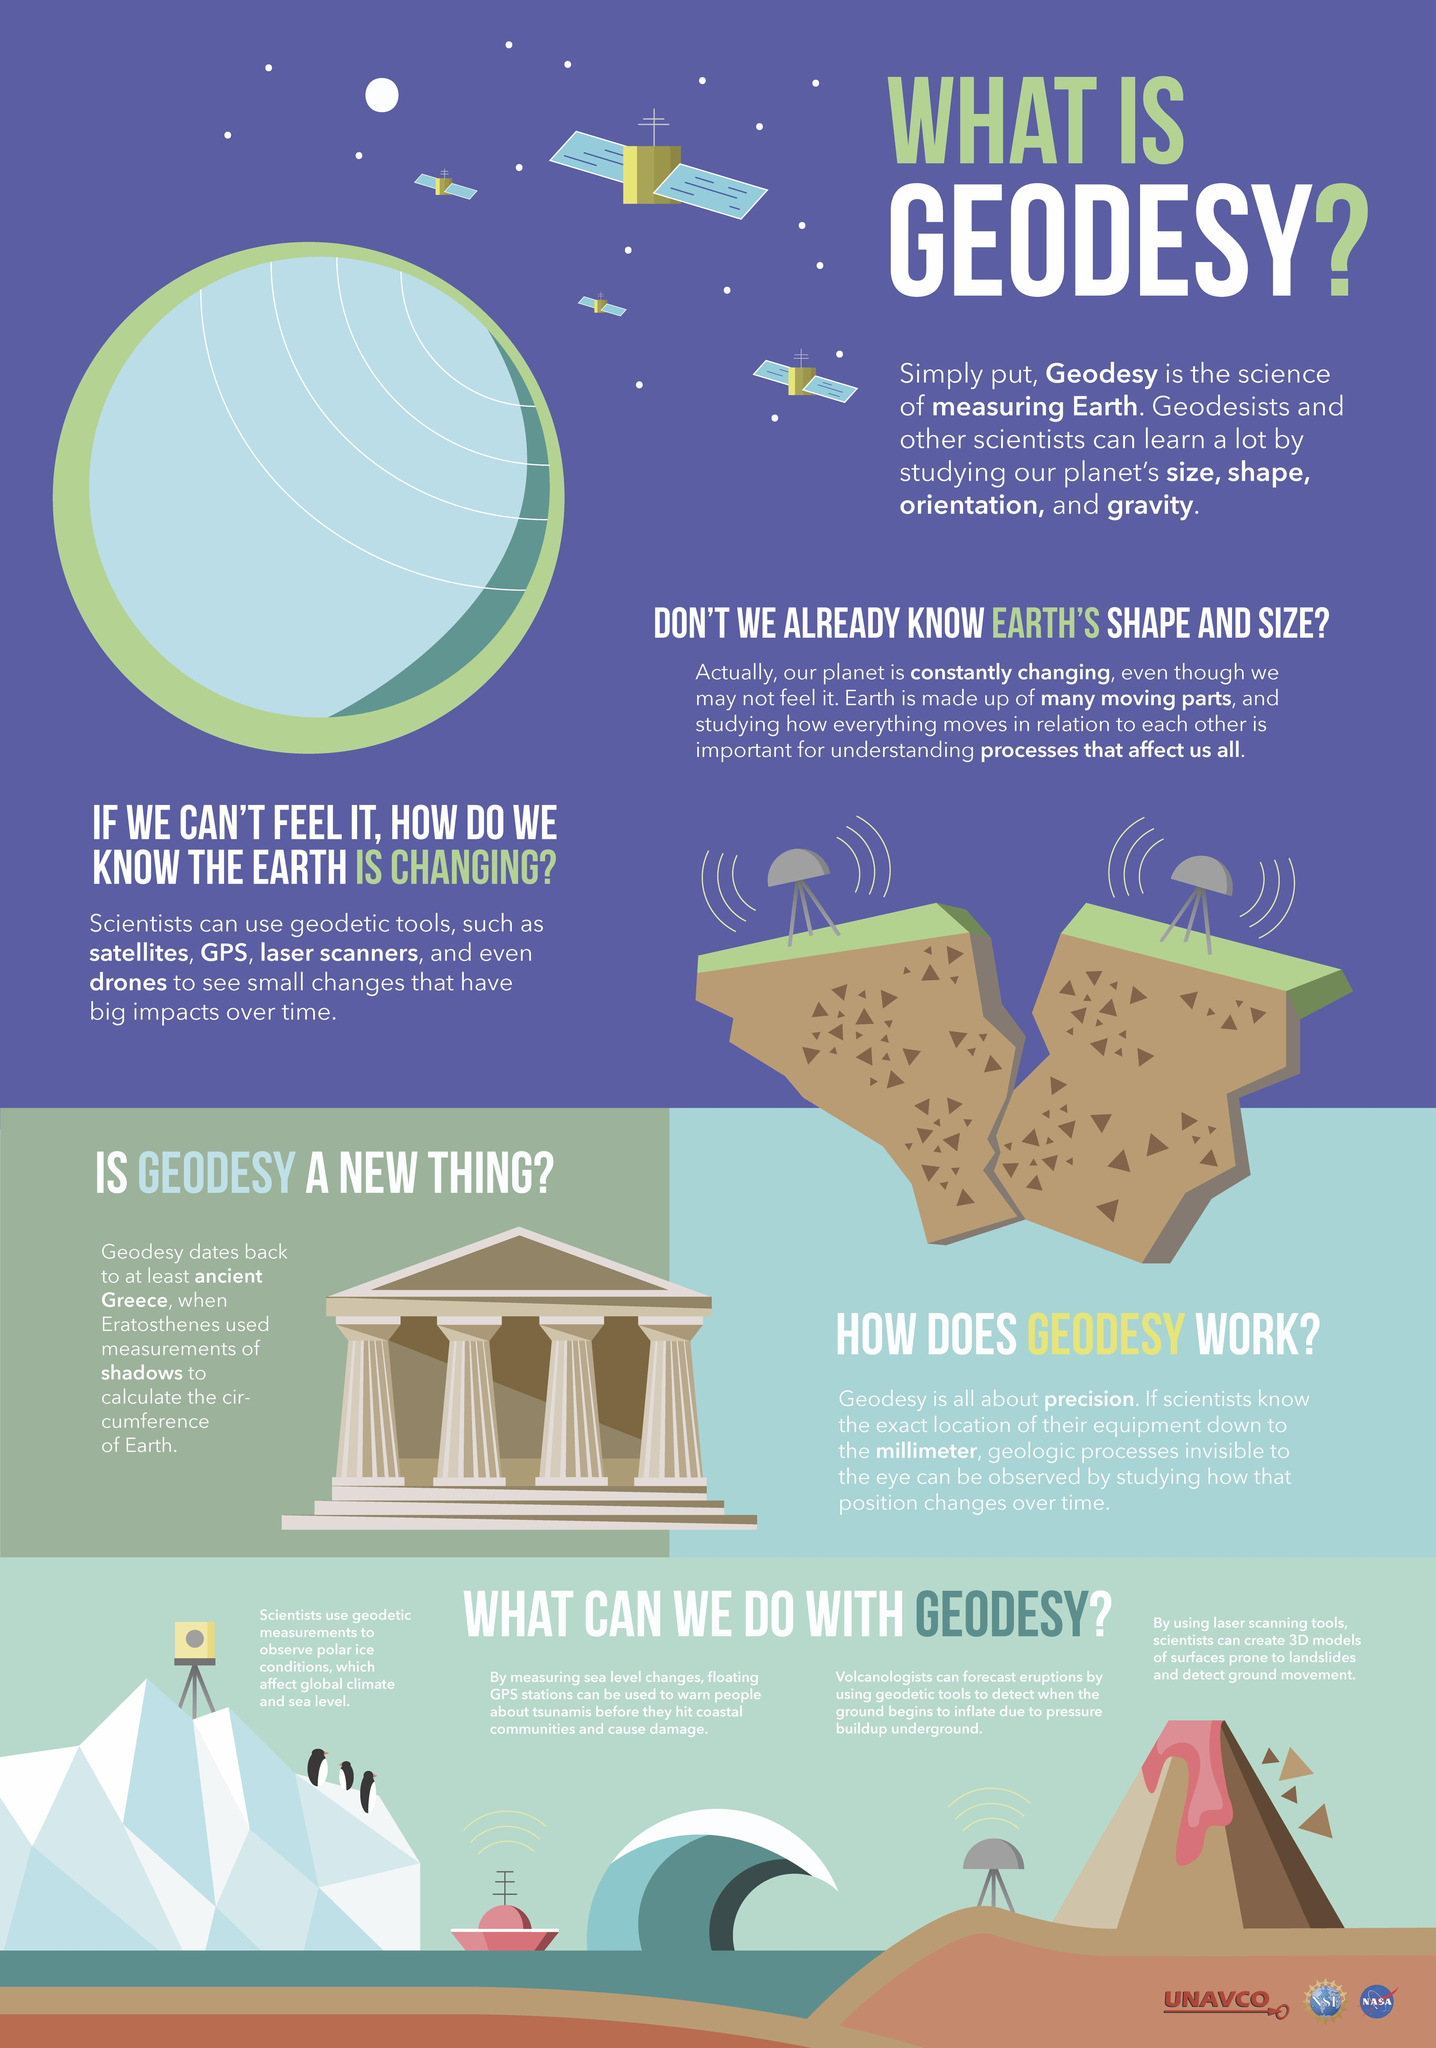Give some essential details in this illustration. There are four satellites depicted in this infographic. 